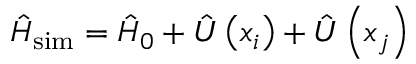<formula> <loc_0><loc_0><loc_500><loc_500>\hat { H } _ { s i m } = \hat { H } _ { 0 } + \hat { U } \left ( x _ { i } \right ) + \hat { U } \left ( x _ { j } \right )</formula> 